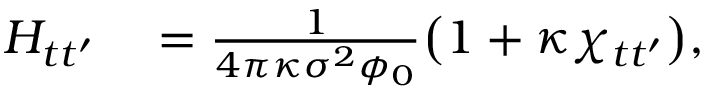Convert formula to latex. <formula><loc_0><loc_0><loc_500><loc_500>\begin{array} { r l } { H _ { t t ^ { \prime } } } & = \frac { 1 } { 4 \pi \kappa \sigma ^ { 2 } \phi _ { 0 } } \left ( 1 + \kappa \chi _ { t t ^ { \prime } } \right ) , } \end{array}</formula> 